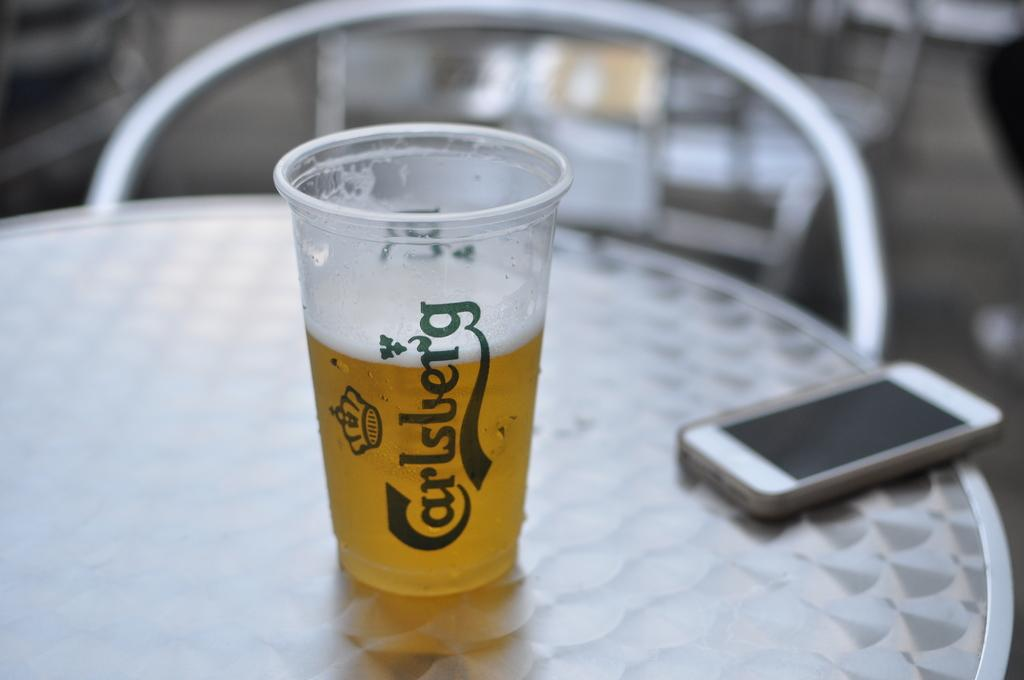<image>
Present a compact description of the photo's key features. a plastic cup on a table that says 'carlsberg' in blue cursive 